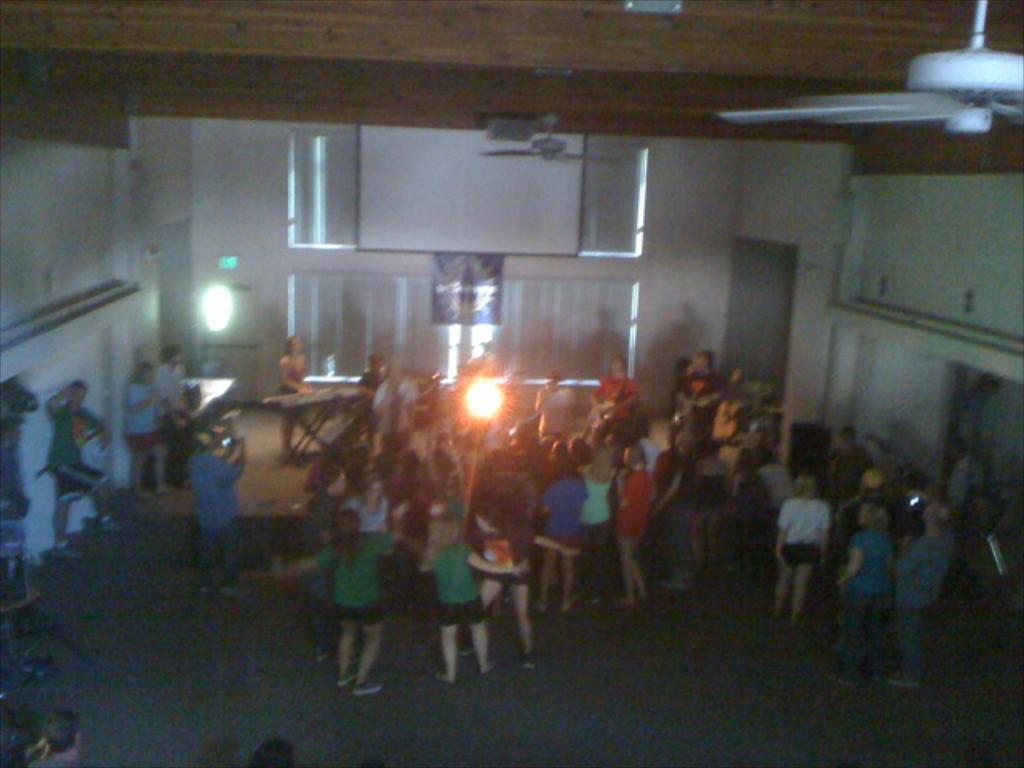Describe this image in one or two sentences. This image is taken inside the room. In this image we can see people standing. We can also see a person standing in front of the table and there are a few people dancing. We can also see a board, banner, wall, fan and also the ceiling. We can also see another fan. At the bottom we can see the surface. Light is also visible. We can also see the flame. 